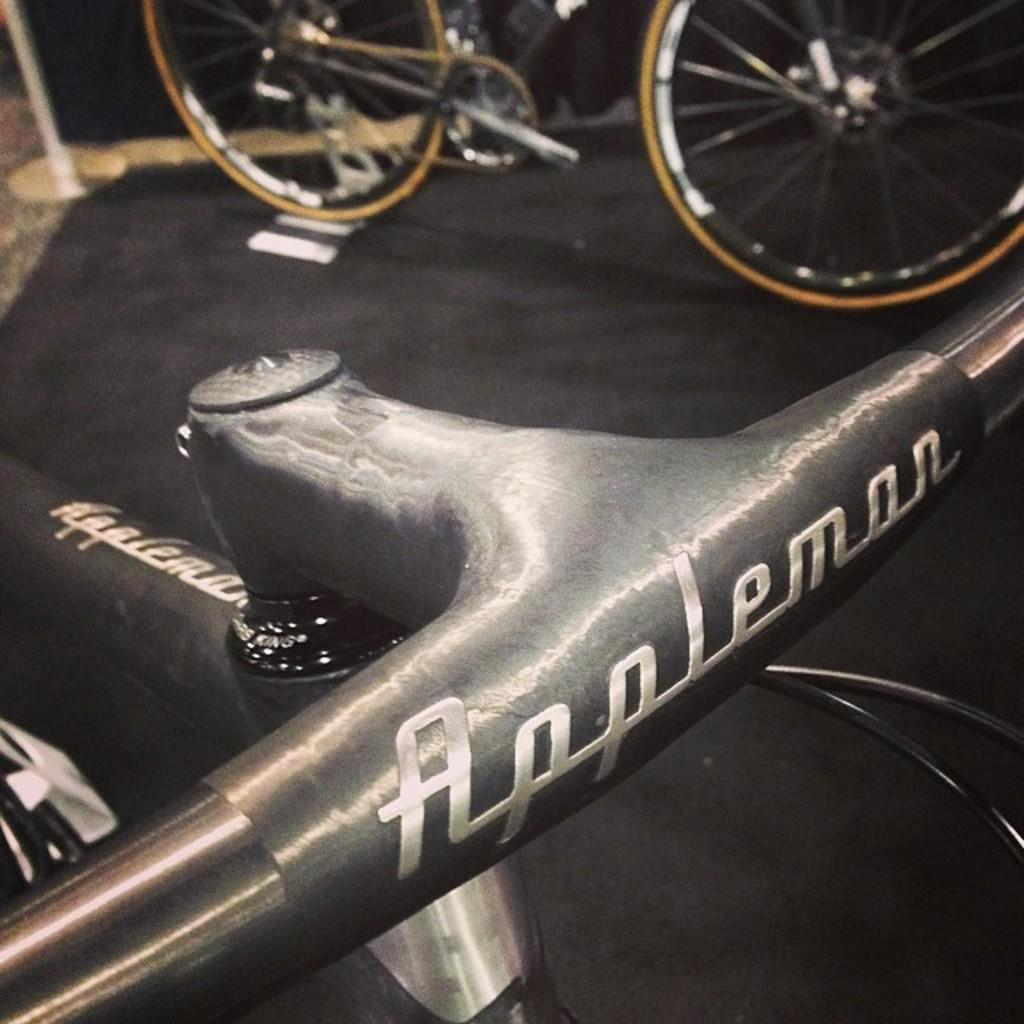What is located in the foreground of the image? In the foreground of the image, there is a bicycle handle and cables. What else can be seen in the foreground of the image? There is also a mat in the foreground of the image. What is visible in the background of the image? In the background of the image, there is a bicycle and a stand. Where is the map located in the image? There is no map present in the image. What type of bells can be heard ringing in the image? There are no bells present in the image, and therefore no sound can be heard. 